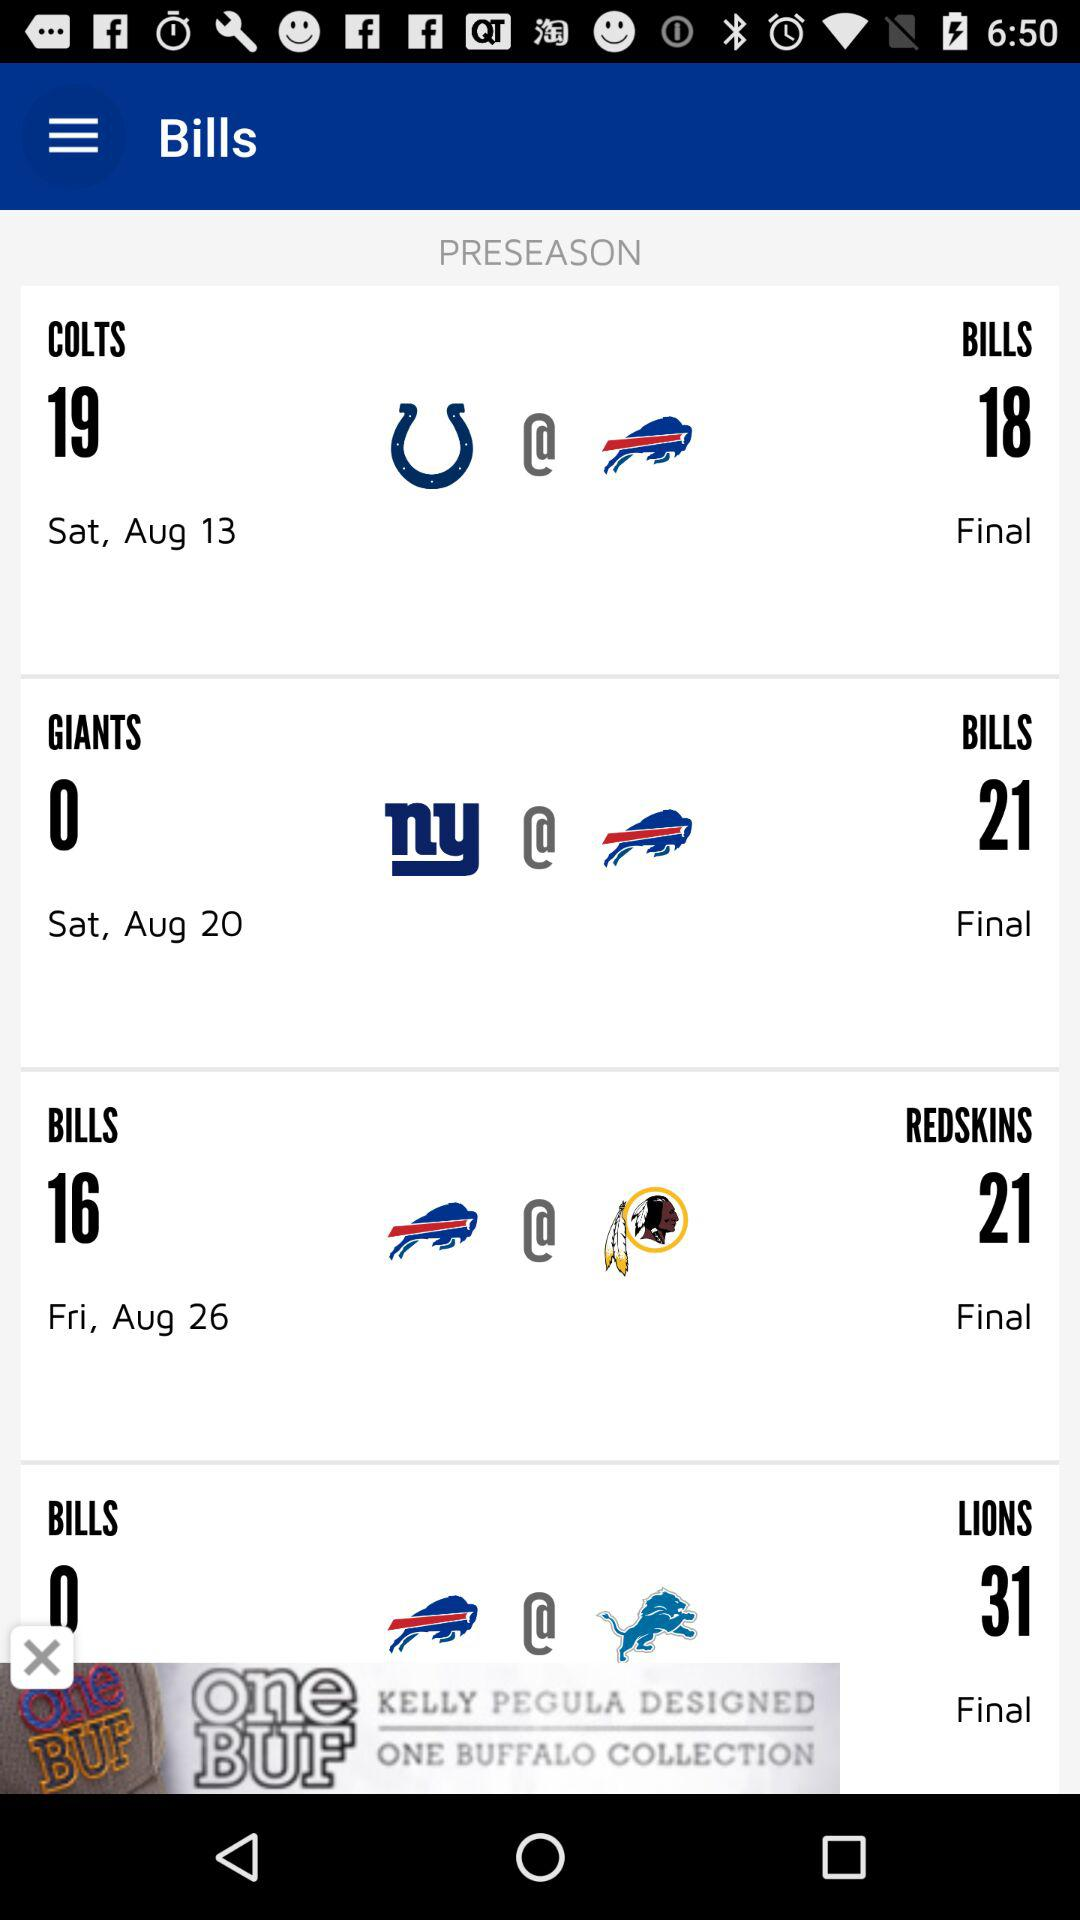On what day "Giants" scored 0? The Giants scored 0 on Saturday. 